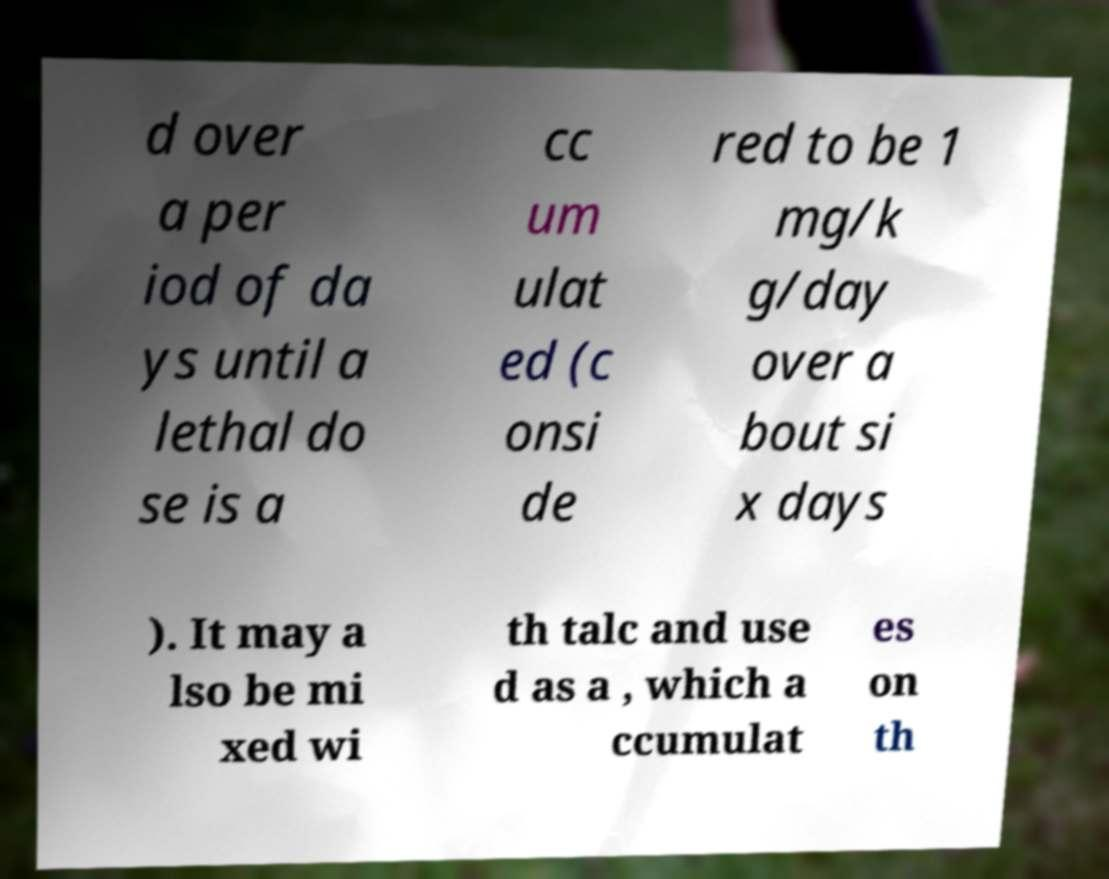What messages or text are displayed in this image? I need them in a readable, typed format. d over a per iod of da ys until a lethal do se is a cc um ulat ed (c onsi de red to be 1 mg/k g/day over a bout si x days ). It may a lso be mi xed wi th talc and use d as a , which a ccumulat es on th 